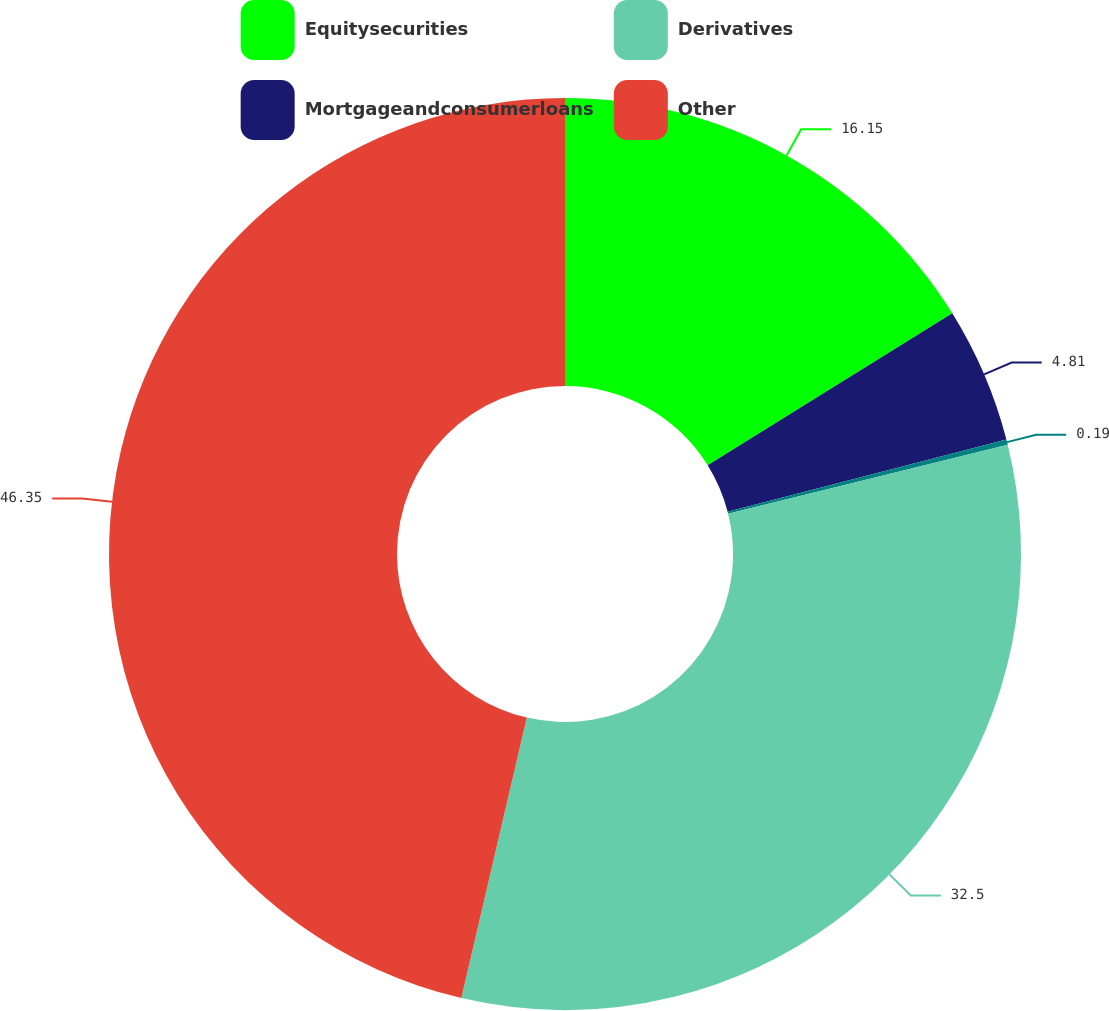Convert chart to OTSL. <chart><loc_0><loc_0><loc_500><loc_500><pie_chart><fcel>Equitysecurities<fcel>Mortgageandconsumerloans<fcel>Unnamed: 2<fcel>Derivatives<fcel>Other<nl><fcel>16.15%<fcel>4.81%<fcel>0.19%<fcel>32.5%<fcel>46.35%<nl></chart> 